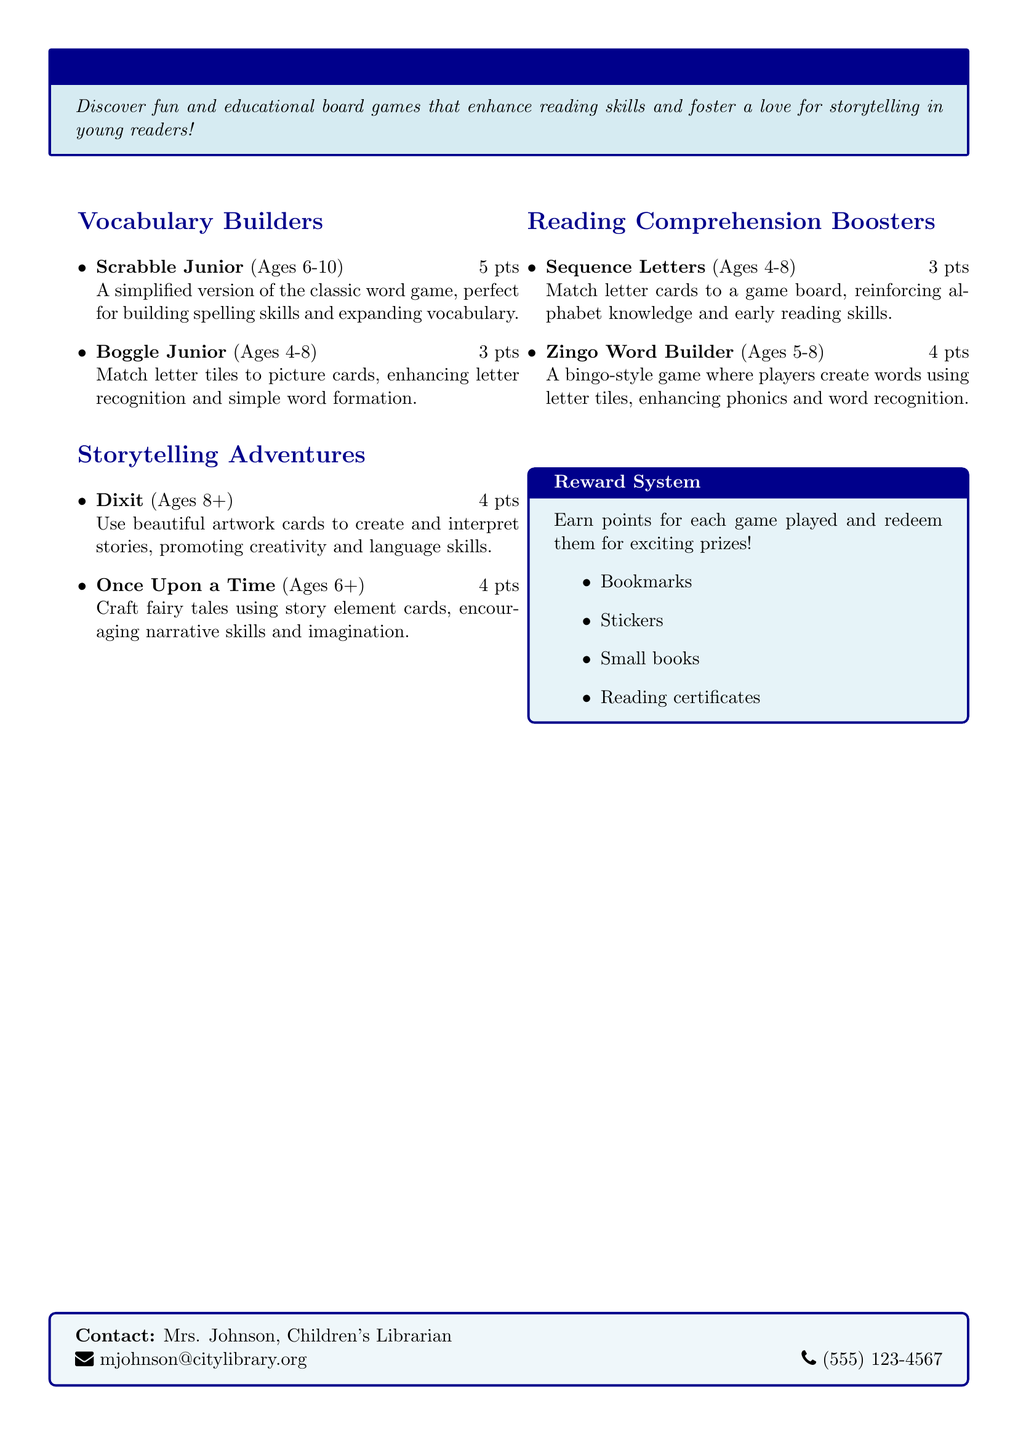What is the name of the board game that enhances spelling skills? The document lists "Scrabble Junior" as a game that builds spelling skills.
Answer: Scrabble Junior What age group is "Boggle Junior" designed for? The document specifies that "Boggle Junior" is for ages 4-8.
Answer: Ages 4-8 How many points do you earn for playing "Zingo Word Builder"? The document states that "Zingo Word Builder" awards 4 points when played.
Answer: 4 points What type of game is "Once Upon a Time"? According to the document, "Once Upon a Time" is a storytelling game that uses story element cards.
Answer: Storytelling Which game helps with reading comprehension for ages 4-8? "Sequence Letters" is mentioned as a game that reinforces alphabet knowledge and early reading skills for that age group.
Answer: Sequence Letters What rewards can be earned by playing the board games? The document lists "Bookmarks, Stickers, Small books, Reading certificates" as rewards.
Answer: Bookmarks, Stickers, Small books, Reading certificates Who should be contacted for more information? The document provides the contact details for Mrs. Johnson, the Children's Librarian.
Answer: Mrs. Johnson What is the main goal of the catalog? The document highlights board games that enhance reading skills and foster a love for storytelling in children.
Answer: Enhance reading skills and storytelling 